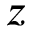<formula> <loc_0><loc_0><loc_500><loc_500>z</formula> 